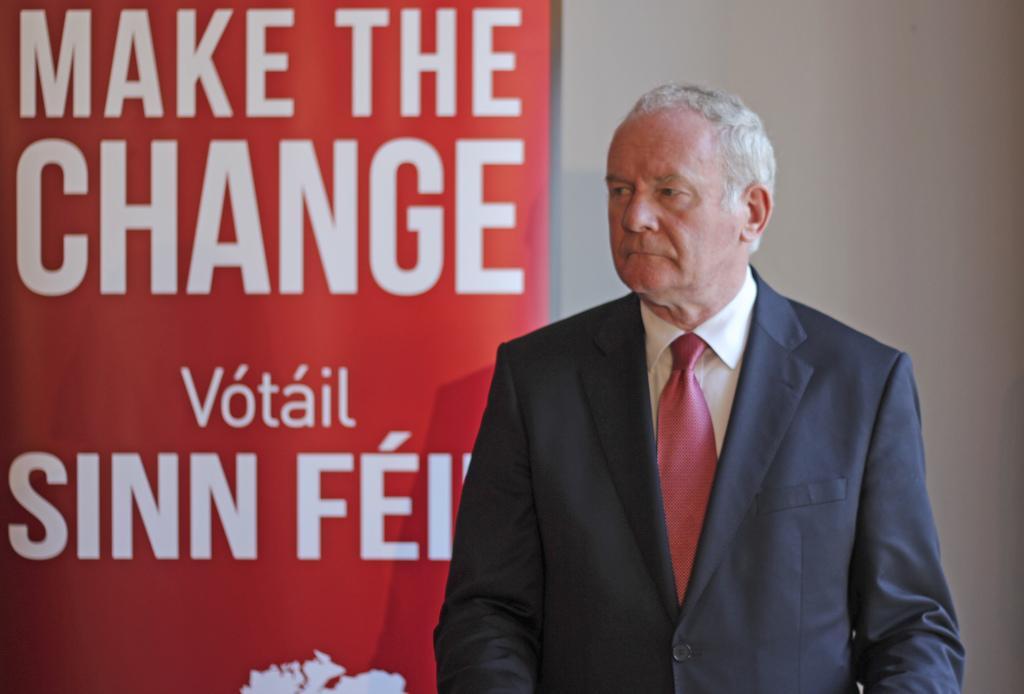In one or two sentences, can you explain what this image depicts? In this image we can see a man standing. In the background there is a banner and we can see a wall. 